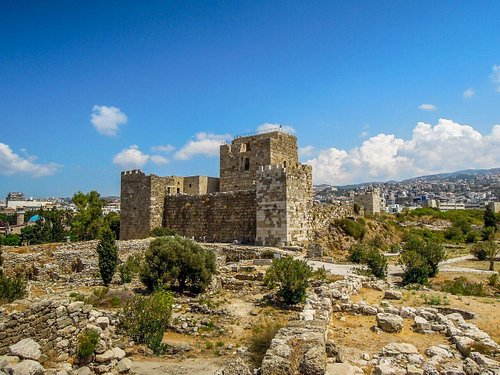What do you think is going on in this snapshot? This image captures the ancient city of Byblos, one of the oldest continuously inhabited cities in the world, located in Lebanon. The foreground shows well-preserved ruins, including stone structures and defensive walls, which highlight the city's historical importance as a major port during Phoenician times. These ruins contrast beautifully with the modern cityscape visible in the background, integrating ancient history with modern life. The serene Mediterranean Sea on the horizon and the clear blue sky complement the warm tones of the stone, making this snapshot a testimony to the city's resilience and enduring beauty through ages. 